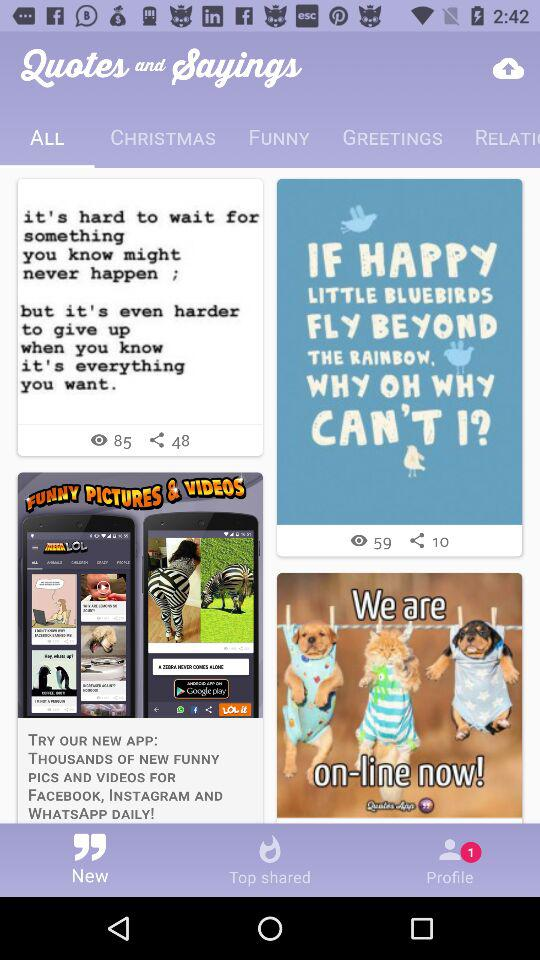What is the name of the application? The name of the application is "Quotes and Sayings". 